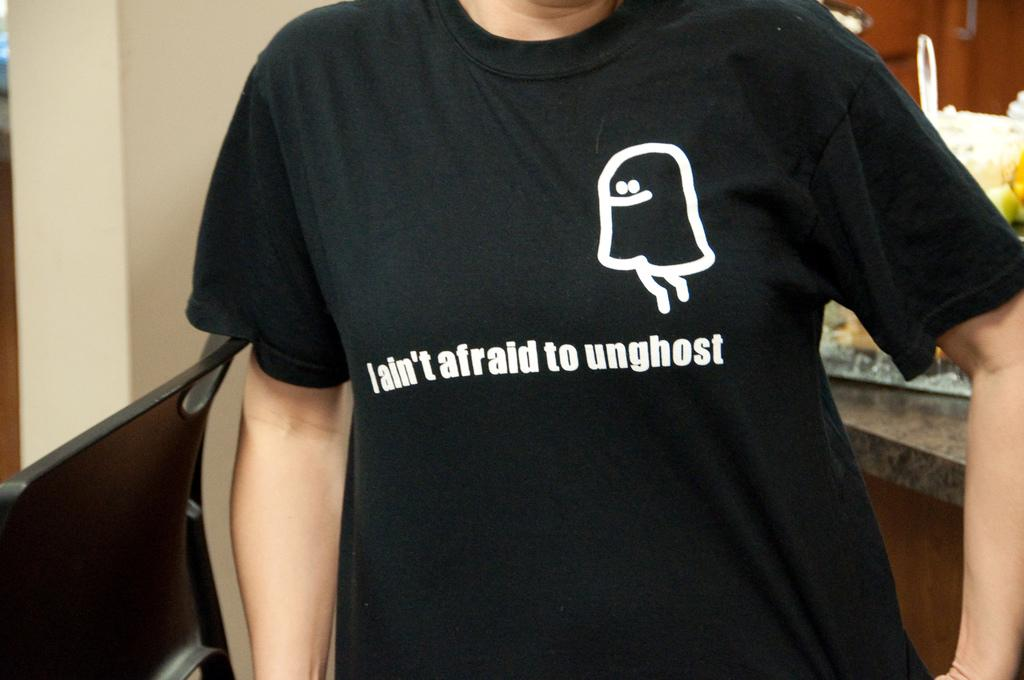<image>
Present a compact description of the photo's key features. Man wearing a shirt that says I ain't afraid to unghost. 